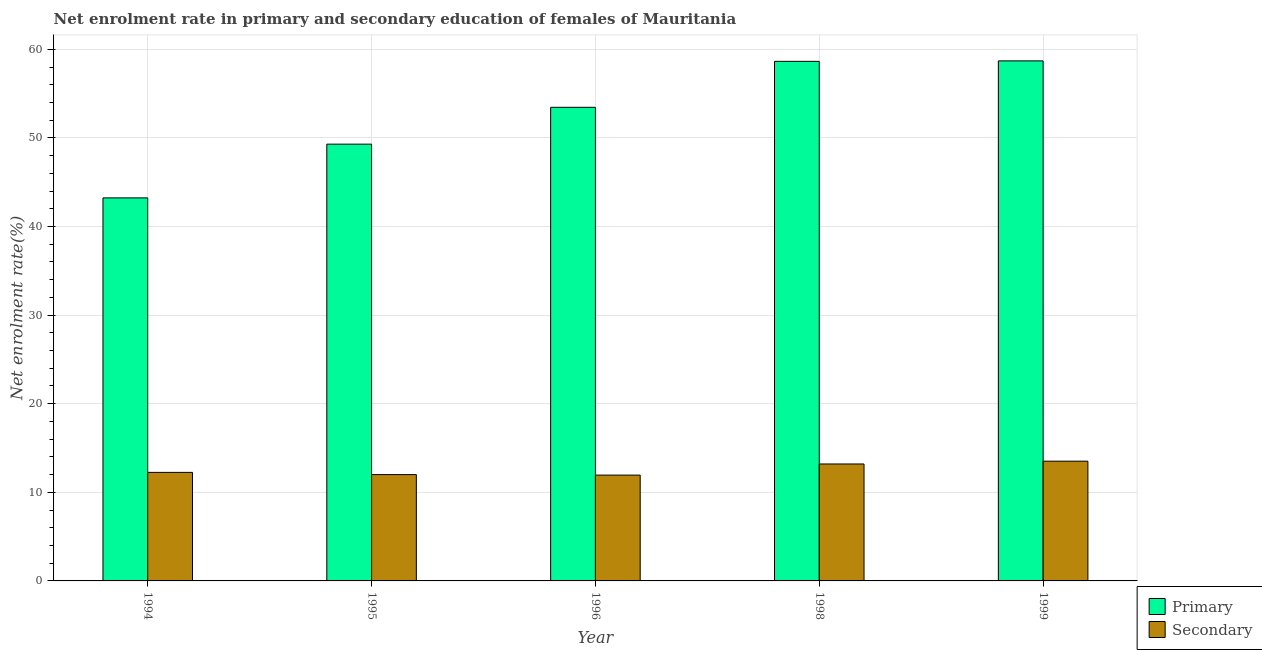How many different coloured bars are there?
Your answer should be very brief. 2. Are the number of bars per tick equal to the number of legend labels?
Your response must be concise. Yes. Are the number of bars on each tick of the X-axis equal?
Make the answer very short. Yes. How many bars are there on the 5th tick from the left?
Offer a very short reply. 2. How many bars are there on the 1st tick from the right?
Your answer should be compact. 2. What is the label of the 4th group of bars from the left?
Offer a very short reply. 1998. What is the enrollment rate in secondary education in 1994?
Make the answer very short. 12.25. Across all years, what is the maximum enrollment rate in primary education?
Offer a very short reply. 58.69. Across all years, what is the minimum enrollment rate in primary education?
Your answer should be compact. 43.23. What is the total enrollment rate in primary education in the graph?
Keep it short and to the point. 263.31. What is the difference between the enrollment rate in primary education in 1995 and that in 1999?
Keep it short and to the point. -9.4. What is the difference between the enrollment rate in secondary education in 1998 and the enrollment rate in primary education in 1999?
Your answer should be very brief. -0.32. What is the average enrollment rate in secondary education per year?
Provide a short and direct response. 12.58. What is the ratio of the enrollment rate in primary education in 1996 to that in 1998?
Give a very brief answer. 0.91. Is the enrollment rate in secondary education in 1994 less than that in 1996?
Your response must be concise. No. What is the difference between the highest and the second highest enrollment rate in primary education?
Your answer should be compact. 0.05. What is the difference between the highest and the lowest enrollment rate in primary education?
Offer a terse response. 15.46. Is the sum of the enrollment rate in primary education in 1994 and 1995 greater than the maximum enrollment rate in secondary education across all years?
Make the answer very short. Yes. What does the 1st bar from the left in 1999 represents?
Your answer should be compact. Primary. What does the 1st bar from the right in 1994 represents?
Your response must be concise. Secondary. Are all the bars in the graph horizontal?
Provide a succinct answer. No. Where does the legend appear in the graph?
Offer a very short reply. Bottom right. How many legend labels are there?
Keep it short and to the point. 2. How are the legend labels stacked?
Provide a succinct answer. Vertical. What is the title of the graph?
Ensure brevity in your answer.  Net enrolment rate in primary and secondary education of females of Mauritania. Does "Imports" appear as one of the legend labels in the graph?
Ensure brevity in your answer.  No. What is the label or title of the Y-axis?
Your answer should be very brief. Net enrolment rate(%). What is the Net enrolment rate(%) of Primary in 1994?
Offer a very short reply. 43.23. What is the Net enrolment rate(%) in Secondary in 1994?
Offer a terse response. 12.25. What is the Net enrolment rate(%) of Primary in 1995?
Provide a succinct answer. 49.3. What is the Net enrolment rate(%) of Secondary in 1995?
Ensure brevity in your answer.  12. What is the Net enrolment rate(%) in Primary in 1996?
Your response must be concise. 53.45. What is the Net enrolment rate(%) of Secondary in 1996?
Provide a succinct answer. 11.94. What is the Net enrolment rate(%) in Primary in 1998?
Your response must be concise. 58.64. What is the Net enrolment rate(%) of Secondary in 1998?
Give a very brief answer. 13.2. What is the Net enrolment rate(%) in Primary in 1999?
Ensure brevity in your answer.  58.69. What is the Net enrolment rate(%) of Secondary in 1999?
Your answer should be very brief. 13.52. Across all years, what is the maximum Net enrolment rate(%) in Primary?
Offer a very short reply. 58.69. Across all years, what is the maximum Net enrolment rate(%) in Secondary?
Your answer should be compact. 13.52. Across all years, what is the minimum Net enrolment rate(%) in Primary?
Offer a very short reply. 43.23. Across all years, what is the minimum Net enrolment rate(%) of Secondary?
Ensure brevity in your answer.  11.94. What is the total Net enrolment rate(%) of Primary in the graph?
Keep it short and to the point. 263.31. What is the total Net enrolment rate(%) of Secondary in the graph?
Give a very brief answer. 62.91. What is the difference between the Net enrolment rate(%) in Primary in 1994 and that in 1995?
Make the answer very short. -6.07. What is the difference between the Net enrolment rate(%) in Secondary in 1994 and that in 1995?
Make the answer very short. 0.25. What is the difference between the Net enrolment rate(%) of Primary in 1994 and that in 1996?
Keep it short and to the point. -10.22. What is the difference between the Net enrolment rate(%) in Secondary in 1994 and that in 1996?
Give a very brief answer. 0.31. What is the difference between the Net enrolment rate(%) of Primary in 1994 and that in 1998?
Your response must be concise. -15.41. What is the difference between the Net enrolment rate(%) in Secondary in 1994 and that in 1998?
Offer a very short reply. -0.95. What is the difference between the Net enrolment rate(%) of Primary in 1994 and that in 1999?
Offer a terse response. -15.46. What is the difference between the Net enrolment rate(%) of Secondary in 1994 and that in 1999?
Provide a short and direct response. -1.27. What is the difference between the Net enrolment rate(%) in Primary in 1995 and that in 1996?
Keep it short and to the point. -4.16. What is the difference between the Net enrolment rate(%) of Secondary in 1995 and that in 1996?
Offer a very short reply. 0.06. What is the difference between the Net enrolment rate(%) in Primary in 1995 and that in 1998?
Ensure brevity in your answer.  -9.34. What is the difference between the Net enrolment rate(%) in Secondary in 1995 and that in 1998?
Your response must be concise. -1.2. What is the difference between the Net enrolment rate(%) in Primary in 1995 and that in 1999?
Your response must be concise. -9.4. What is the difference between the Net enrolment rate(%) in Secondary in 1995 and that in 1999?
Offer a very short reply. -1.51. What is the difference between the Net enrolment rate(%) in Primary in 1996 and that in 1998?
Your answer should be very brief. -5.19. What is the difference between the Net enrolment rate(%) in Secondary in 1996 and that in 1998?
Give a very brief answer. -1.26. What is the difference between the Net enrolment rate(%) in Primary in 1996 and that in 1999?
Your answer should be very brief. -5.24. What is the difference between the Net enrolment rate(%) in Secondary in 1996 and that in 1999?
Your response must be concise. -1.57. What is the difference between the Net enrolment rate(%) in Primary in 1998 and that in 1999?
Keep it short and to the point. -0.05. What is the difference between the Net enrolment rate(%) of Secondary in 1998 and that in 1999?
Provide a succinct answer. -0.32. What is the difference between the Net enrolment rate(%) of Primary in 1994 and the Net enrolment rate(%) of Secondary in 1995?
Make the answer very short. 31.23. What is the difference between the Net enrolment rate(%) of Primary in 1994 and the Net enrolment rate(%) of Secondary in 1996?
Make the answer very short. 31.29. What is the difference between the Net enrolment rate(%) in Primary in 1994 and the Net enrolment rate(%) in Secondary in 1998?
Provide a succinct answer. 30.03. What is the difference between the Net enrolment rate(%) of Primary in 1994 and the Net enrolment rate(%) of Secondary in 1999?
Offer a terse response. 29.71. What is the difference between the Net enrolment rate(%) in Primary in 1995 and the Net enrolment rate(%) in Secondary in 1996?
Make the answer very short. 37.35. What is the difference between the Net enrolment rate(%) of Primary in 1995 and the Net enrolment rate(%) of Secondary in 1998?
Your answer should be very brief. 36.1. What is the difference between the Net enrolment rate(%) in Primary in 1995 and the Net enrolment rate(%) in Secondary in 1999?
Your answer should be very brief. 35.78. What is the difference between the Net enrolment rate(%) in Primary in 1996 and the Net enrolment rate(%) in Secondary in 1998?
Your answer should be compact. 40.25. What is the difference between the Net enrolment rate(%) in Primary in 1996 and the Net enrolment rate(%) in Secondary in 1999?
Your response must be concise. 39.94. What is the difference between the Net enrolment rate(%) in Primary in 1998 and the Net enrolment rate(%) in Secondary in 1999?
Keep it short and to the point. 45.12. What is the average Net enrolment rate(%) in Primary per year?
Make the answer very short. 52.66. What is the average Net enrolment rate(%) of Secondary per year?
Your answer should be compact. 12.58. In the year 1994, what is the difference between the Net enrolment rate(%) in Primary and Net enrolment rate(%) in Secondary?
Offer a terse response. 30.98. In the year 1995, what is the difference between the Net enrolment rate(%) of Primary and Net enrolment rate(%) of Secondary?
Offer a very short reply. 37.29. In the year 1996, what is the difference between the Net enrolment rate(%) in Primary and Net enrolment rate(%) in Secondary?
Your answer should be compact. 41.51. In the year 1998, what is the difference between the Net enrolment rate(%) in Primary and Net enrolment rate(%) in Secondary?
Provide a succinct answer. 45.44. In the year 1999, what is the difference between the Net enrolment rate(%) of Primary and Net enrolment rate(%) of Secondary?
Offer a terse response. 45.18. What is the ratio of the Net enrolment rate(%) of Primary in 1994 to that in 1995?
Your response must be concise. 0.88. What is the ratio of the Net enrolment rate(%) of Secondary in 1994 to that in 1995?
Your response must be concise. 1.02. What is the ratio of the Net enrolment rate(%) of Primary in 1994 to that in 1996?
Your response must be concise. 0.81. What is the ratio of the Net enrolment rate(%) in Secondary in 1994 to that in 1996?
Your answer should be very brief. 1.03. What is the ratio of the Net enrolment rate(%) in Primary in 1994 to that in 1998?
Keep it short and to the point. 0.74. What is the ratio of the Net enrolment rate(%) in Secondary in 1994 to that in 1998?
Offer a very short reply. 0.93. What is the ratio of the Net enrolment rate(%) in Primary in 1994 to that in 1999?
Your response must be concise. 0.74. What is the ratio of the Net enrolment rate(%) of Secondary in 1994 to that in 1999?
Make the answer very short. 0.91. What is the ratio of the Net enrolment rate(%) in Primary in 1995 to that in 1996?
Provide a succinct answer. 0.92. What is the ratio of the Net enrolment rate(%) of Secondary in 1995 to that in 1996?
Provide a succinct answer. 1. What is the ratio of the Net enrolment rate(%) of Primary in 1995 to that in 1998?
Your answer should be compact. 0.84. What is the ratio of the Net enrolment rate(%) in Secondary in 1995 to that in 1998?
Your response must be concise. 0.91. What is the ratio of the Net enrolment rate(%) in Primary in 1995 to that in 1999?
Your answer should be compact. 0.84. What is the ratio of the Net enrolment rate(%) in Secondary in 1995 to that in 1999?
Offer a very short reply. 0.89. What is the ratio of the Net enrolment rate(%) of Primary in 1996 to that in 1998?
Ensure brevity in your answer.  0.91. What is the ratio of the Net enrolment rate(%) of Secondary in 1996 to that in 1998?
Keep it short and to the point. 0.9. What is the ratio of the Net enrolment rate(%) in Primary in 1996 to that in 1999?
Provide a succinct answer. 0.91. What is the ratio of the Net enrolment rate(%) of Secondary in 1996 to that in 1999?
Offer a terse response. 0.88. What is the ratio of the Net enrolment rate(%) of Secondary in 1998 to that in 1999?
Your answer should be compact. 0.98. What is the difference between the highest and the second highest Net enrolment rate(%) in Primary?
Keep it short and to the point. 0.05. What is the difference between the highest and the second highest Net enrolment rate(%) of Secondary?
Provide a short and direct response. 0.32. What is the difference between the highest and the lowest Net enrolment rate(%) in Primary?
Ensure brevity in your answer.  15.46. What is the difference between the highest and the lowest Net enrolment rate(%) of Secondary?
Your response must be concise. 1.57. 